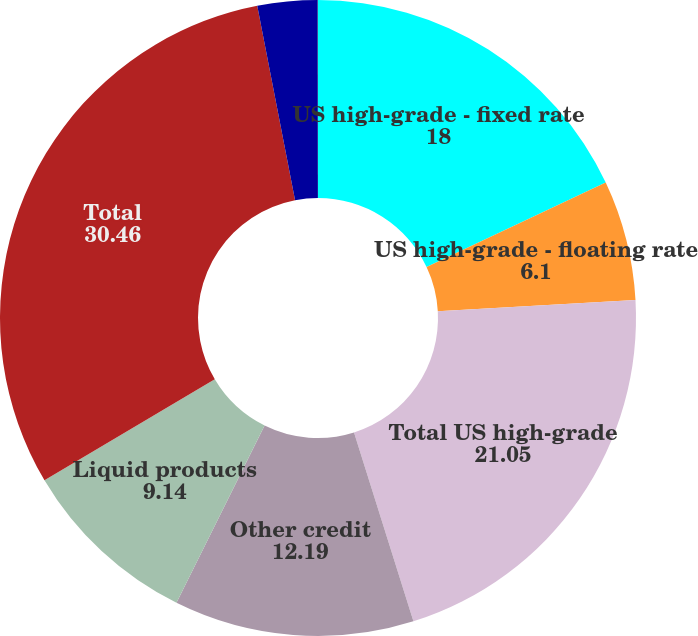Convert chart to OTSL. <chart><loc_0><loc_0><loc_500><loc_500><pie_chart><fcel>US high-grade - fixed rate<fcel>US high-grade - floating rate<fcel>Total US high-grade<fcel>Other credit<fcel>Liquid products<fcel>Total<fcel>Number of US trading days<fcel>Number of UK trading days<nl><fcel>18.0%<fcel>6.1%<fcel>21.05%<fcel>12.19%<fcel>9.14%<fcel>30.46%<fcel>3.05%<fcel>0.01%<nl></chart> 